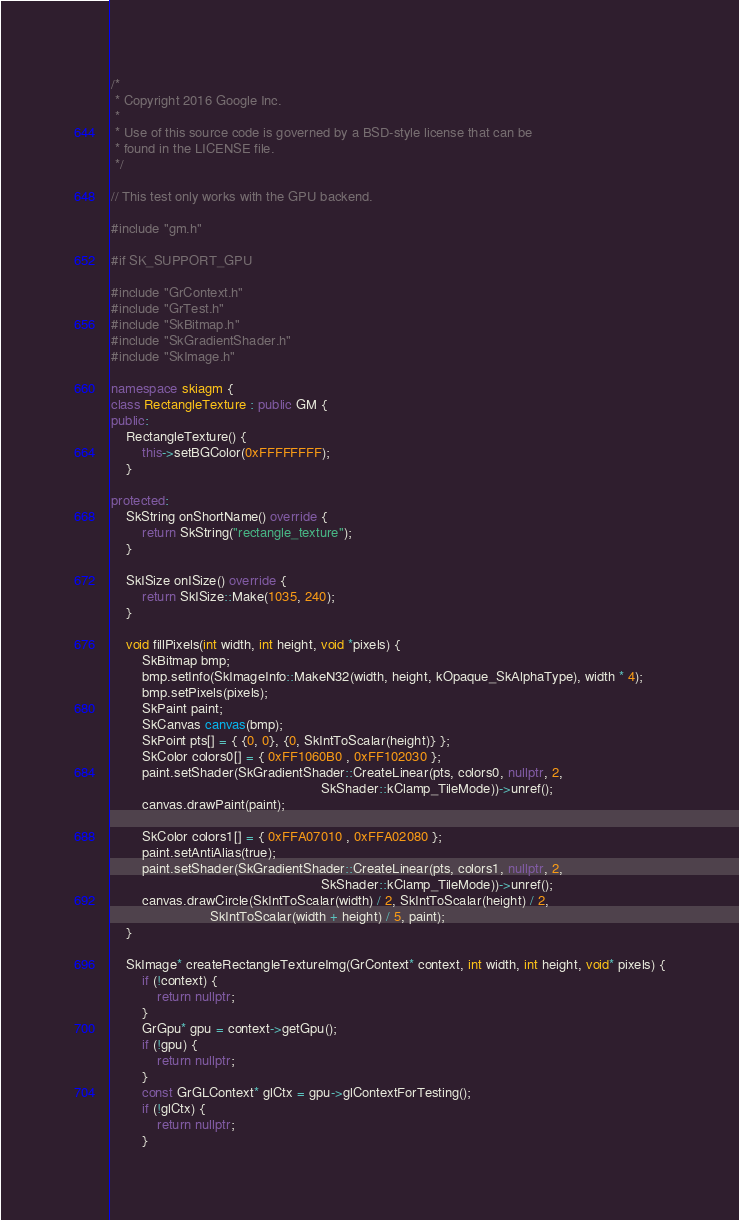<code> <loc_0><loc_0><loc_500><loc_500><_C++_>
/*
 * Copyright 2016 Google Inc.
 *
 * Use of this source code is governed by a BSD-style license that can be
 * found in the LICENSE file.
 */

// This test only works with the GPU backend.

#include "gm.h"

#if SK_SUPPORT_GPU

#include "GrContext.h"
#include "GrTest.h"
#include "SkBitmap.h"
#include "SkGradientShader.h"
#include "SkImage.h"

namespace skiagm {
class RectangleTexture : public GM {
public:
    RectangleTexture() {
        this->setBGColor(0xFFFFFFFF);
    }

protected:
    SkString onShortName() override {
        return SkString("rectangle_texture");
    }

    SkISize onISize() override {
        return SkISize::Make(1035, 240);
    }

    void fillPixels(int width, int height, void *pixels) {
        SkBitmap bmp;
        bmp.setInfo(SkImageInfo::MakeN32(width, height, kOpaque_SkAlphaType), width * 4);
        bmp.setPixels(pixels);
        SkPaint paint;
        SkCanvas canvas(bmp);
        SkPoint pts[] = { {0, 0}, {0, SkIntToScalar(height)} };
        SkColor colors0[] = { 0xFF1060B0 , 0xFF102030 };
        paint.setShader(SkGradientShader::CreateLinear(pts, colors0, nullptr, 2,
                                                       SkShader::kClamp_TileMode))->unref();
        canvas.drawPaint(paint);

        SkColor colors1[] = { 0xFFA07010 , 0xFFA02080 };
        paint.setAntiAlias(true);
        paint.setShader(SkGradientShader::CreateLinear(pts, colors1, nullptr, 2,
                                                       SkShader::kClamp_TileMode))->unref();
        canvas.drawCircle(SkIntToScalar(width) / 2, SkIntToScalar(height) / 2,
                          SkIntToScalar(width + height) / 5, paint);
    }

    SkImage* createRectangleTextureImg(GrContext* context, int width, int height, void* pixels) {
        if (!context) {
            return nullptr;
        }
        GrGpu* gpu = context->getGpu();
        if (!gpu) {
            return nullptr;
        }
        const GrGLContext* glCtx = gpu->glContextForTesting();
        if (!glCtx) {
            return nullptr;
        }
</code> 